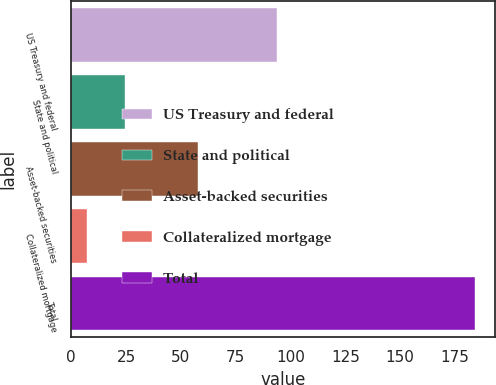Convert chart to OTSL. <chart><loc_0><loc_0><loc_500><loc_500><bar_chart><fcel>US Treasury and federal<fcel>State and political<fcel>Asset-backed securities<fcel>Collateralized mortgage<fcel>Total<nl><fcel>94<fcel>24.7<fcel>58<fcel>7<fcel>184<nl></chart> 